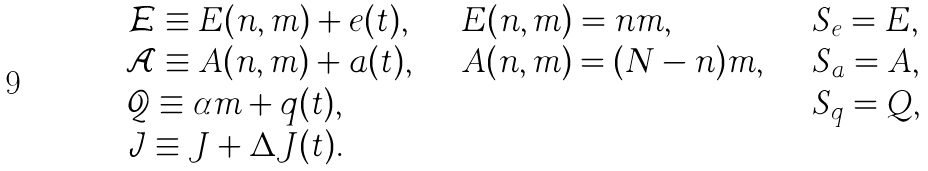Convert formula to latex. <formula><loc_0><loc_0><loc_500><loc_500>\begin{array} { l l l } { \mathcal { E } } \equiv E ( n , m ) + e ( t ) , \quad & E ( n , m ) = n m , \quad & S _ { e } = E , \\ { \mathcal { A } } \equiv A ( n , m ) + a ( t ) , \quad & A ( n , m ) = ( N - n ) m , \quad & S _ { a } = A , \\ { \mathcal { Q } } \equiv \alpha m + q ( t ) , \quad & & S _ { q } = Q , \\ { \mathcal { J } } \equiv J + \Delta J ( t ) . & & \end{array}</formula> 